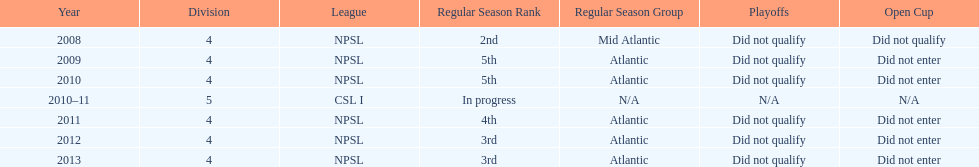What is the lowest place they came in 5th. Would you mind parsing the complete table? {'header': ['Year', 'Division', 'League', 'Regular Season Rank', 'Regular Season Group', 'Playoffs', 'Open Cup'], 'rows': [['2008', '4', 'NPSL', '2nd', 'Mid Atlantic', 'Did not qualify', 'Did not qualify'], ['2009', '4', 'NPSL', '5th', 'Atlantic', 'Did not qualify', 'Did not enter'], ['2010', '4', 'NPSL', '5th', 'Atlantic', 'Did not qualify', 'Did not enter'], ['2010–11', '5', 'CSL I', 'In progress', 'N/A', 'N/A', 'N/A'], ['2011', '4', 'NPSL', '4th', 'Atlantic', 'Did not qualify', 'Did not enter'], ['2012', '4', 'NPSL', '3rd', 'Atlantic', 'Did not qualify', 'Did not enter'], ['2013', '4', 'NPSL', '3rd', 'Atlantic', 'Did not qualify', 'Did not enter']]} 